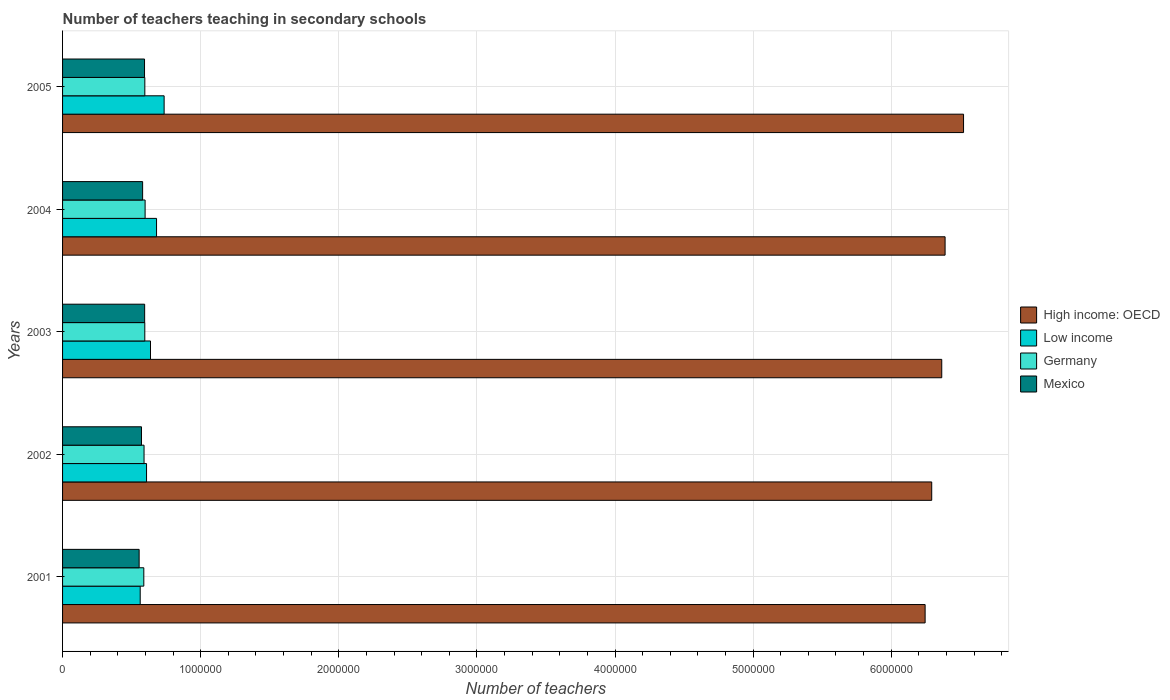How many different coloured bars are there?
Your response must be concise. 4. Are the number of bars per tick equal to the number of legend labels?
Your answer should be compact. Yes. How many bars are there on the 4th tick from the top?
Ensure brevity in your answer.  4. In how many cases, is the number of bars for a given year not equal to the number of legend labels?
Your answer should be compact. 0. What is the number of teachers teaching in secondary schools in Germany in 2005?
Make the answer very short. 5.96e+05. Across all years, what is the maximum number of teachers teaching in secondary schools in Germany?
Make the answer very short. 5.98e+05. Across all years, what is the minimum number of teachers teaching in secondary schools in Mexico?
Ensure brevity in your answer.  5.54e+05. In which year was the number of teachers teaching in secondary schools in Mexico maximum?
Ensure brevity in your answer.  2003. What is the total number of teachers teaching in secondary schools in Germany in the graph?
Make the answer very short. 2.97e+06. What is the difference between the number of teachers teaching in secondary schools in Low income in 2002 and that in 2004?
Your answer should be compact. -7.24e+04. What is the difference between the number of teachers teaching in secondary schools in High income: OECD in 2003 and the number of teachers teaching in secondary schools in Low income in 2002?
Offer a terse response. 5.76e+06. What is the average number of teachers teaching in secondary schools in Germany per year?
Provide a short and direct response. 5.93e+05. In the year 2003, what is the difference between the number of teachers teaching in secondary schools in High income: OECD and number of teachers teaching in secondary schools in Mexico?
Your response must be concise. 5.77e+06. In how many years, is the number of teachers teaching in secondary schools in Low income greater than 3800000 ?
Keep it short and to the point. 0. What is the ratio of the number of teachers teaching in secondary schools in Low income in 2001 to that in 2003?
Offer a terse response. 0.88. Is the number of teachers teaching in secondary schools in Low income in 2001 less than that in 2003?
Keep it short and to the point. Yes. Is the difference between the number of teachers teaching in secondary schools in High income: OECD in 2002 and 2003 greater than the difference between the number of teachers teaching in secondary schools in Mexico in 2002 and 2003?
Make the answer very short. No. What is the difference between the highest and the second highest number of teachers teaching in secondary schools in Germany?
Ensure brevity in your answer.  2046. What is the difference between the highest and the lowest number of teachers teaching in secondary schools in Low income?
Your response must be concise. 1.73e+05. In how many years, is the number of teachers teaching in secondary schools in Mexico greater than the average number of teachers teaching in secondary schools in Mexico taken over all years?
Keep it short and to the point. 3. Is the sum of the number of teachers teaching in secondary schools in Mexico in 2003 and 2004 greater than the maximum number of teachers teaching in secondary schools in Germany across all years?
Keep it short and to the point. Yes. Is it the case that in every year, the sum of the number of teachers teaching in secondary schools in Mexico and number of teachers teaching in secondary schools in High income: OECD is greater than the sum of number of teachers teaching in secondary schools in Low income and number of teachers teaching in secondary schools in Germany?
Offer a very short reply. Yes. What does the 2nd bar from the top in 2003 represents?
Make the answer very short. Germany. What does the 2nd bar from the bottom in 2005 represents?
Your answer should be compact. Low income. Is it the case that in every year, the sum of the number of teachers teaching in secondary schools in High income: OECD and number of teachers teaching in secondary schools in Mexico is greater than the number of teachers teaching in secondary schools in Low income?
Ensure brevity in your answer.  Yes. Are all the bars in the graph horizontal?
Keep it short and to the point. Yes. What is the difference between two consecutive major ticks on the X-axis?
Give a very brief answer. 1.00e+06. Are the values on the major ticks of X-axis written in scientific E-notation?
Keep it short and to the point. No. Does the graph contain any zero values?
Give a very brief answer. No. Does the graph contain grids?
Ensure brevity in your answer.  Yes. Where does the legend appear in the graph?
Your answer should be compact. Center right. What is the title of the graph?
Offer a very short reply. Number of teachers teaching in secondary schools. Does "Tanzania" appear as one of the legend labels in the graph?
Keep it short and to the point. No. What is the label or title of the X-axis?
Offer a very short reply. Number of teachers. What is the label or title of the Y-axis?
Keep it short and to the point. Years. What is the Number of teachers in High income: OECD in 2001?
Offer a terse response. 6.25e+06. What is the Number of teachers of Low income in 2001?
Ensure brevity in your answer.  5.62e+05. What is the Number of teachers in Germany in 2001?
Offer a terse response. 5.88e+05. What is the Number of teachers of Mexico in 2001?
Offer a terse response. 5.54e+05. What is the Number of teachers in High income: OECD in 2002?
Offer a very short reply. 6.29e+06. What is the Number of teachers in Low income in 2002?
Offer a very short reply. 6.08e+05. What is the Number of teachers in Germany in 2002?
Keep it short and to the point. 5.90e+05. What is the Number of teachers of Mexico in 2002?
Keep it short and to the point. 5.71e+05. What is the Number of teachers of High income: OECD in 2003?
Keep it short and to the point. 6.37e+06. What is the Number of teachers of Low income in 2003?
Keep it short and to the point. 6.37e+05. What is the Number of teachers of Germany in 2003?
Provide a succinct answer. 5.95e+05. What is the Number of teachers of Mexico in 2003?
Make the answer very short. 5.94e+05. What is the Number of teachers in High income: OECD in 2004?
Give a very brief answer. 6.39e+06. What is the Number of teachers in Low income in 2004?
Your answer should be compact. 6.80e+05. What is the Number of teachers in Germany in 2004?
Your answer should be compact. 5.98e+05. What is the Number of teachers in Mexico in 2004?
Offer a terse response. 5.80e+05. What is the Number of teachers of High income: OECD in 2005?
Make the answer very short. 6.52e+06. What is the Number of teachers in Low income in 2005?
Your answer should be compact. 7.35e+05. What is the Number of teachers of Germany in 2005?
Ensure brevity in your answer.  5.96e+05. What is the Number of teachers of Mexico in 2005?
Your response must be concise. 5.93e+05. Across all years, what is the maximum Number of teachers in High income: OECD?
Give a very brief answer. 6.52e+06. Across all years, what is the maximum Number of teachers of Low income?
Your answer should be compact. 7.35e+05. Across all years, what is the maximum Number of teachers in Germany?
Your response must be concise. 5.98e+05. Across all years, what is the maximum Number of teachers in Mexico?
Give a very brief answer. 5.94e+05. Across all years, what is the minimum Number of teachers of High income: OECD?
Give a very brief answer. 6.25e+06. Across all years, what is the minimum Number of teachers of Low income?
Provide a short and direct response. 5.62e+05. Across all years, what is the minimum Number of teachers in Germany?
Your answer should be compact. 5.88e+05. Across all years, what is the minimum Number of teachers of Mexico?
Make the answer very short. 5.54e+05. What is the total Number of teachers of High income: OECD in the graph?
Offer a very short reply. 3.18e+07. What is the total Number of teachers in Low income in the graph?
Ensure brevity in your answer.  3.22e+06. What is the total Number of teachers of Germany in the graph?
Your answer should be very brief. 2.97e+06. What is the total Number of teachers of Mexico in the graph?
Make the answer very short. 2.89e+06. What is the difference between the Number of teachers in High income: OECD in 2001 and that in 2002?
Provide a short and direct response. -4.78e+04. What is the difference between the Number of teachers of Low income in 2001 and that in 2002?
Provide a succinct answer. -4.59e+04. What is the difference between the Number of teachers in Germany in 2001 and that in 2002?
Your answer should be very brief. -1636. What is the difference between the Number of teachers of Mexico in 2001 and that in 2002?
Your answer should be very brief. -1.70e+04. What is the difference between the Number of teachers of High income: OECD in 2001 and that in 2003?
Offer a very short reply. -1.20e+05. What is the difference between the Number of teachers in Low income in 2001 and that in 2003?
Offer a terse response. -7.46e+04. What is the difference between the Number of teachers in Germany in 2001 and that in 2003?
Provide a short and direct response. -7059. What is the difference between the Number of teachers of Mexico in 2001 and that in 2003?
Keep it short and to the point. -4.00e+04. What is the difference between the Number of teachers in High income: OECD in 2001 and that in 2004?
Provide a succinct answer. -1.45e+05. What is the difference between the Number of teachers of Low income in 2001 and that in 2004?
Your response must be concise. -1.18e+05. What is the difference between the Number of teachers in Germany in 2001 and that in 2004?
Provide a short and direct response. -9352. What is the difference between the Number of teachers in Mexico in 2001 and that in 2004?
Offer a terse response. -2.53e+04. What is the difference between the Number of teachers in High income: OECD in 2001 and that in 2005?
Ensure brevity in your answer.  -2.78e+05. What is the difference between the Number of teachers of Low income in 2001 and that in 2005?
Keep it short and to the point. -1.73e+05. What is the difference between the Number of teachers in Germany in 2001 and that in 2005?
Offer a very short reply. -7306. What is the difference between the Number of teachers of Mexico in 2001 and that in 2005?
Make the answer very short. -3.90e+04. What is the difference between the Number of teachers of High income: OECD in 2002 and that in 2003?
Make the answer very short. -7.26e+04. What is the difference between the Number of teachers of Low income in 2002 and that in 2003?
Your response must be concise. -2.87e+04. What is the difference between the Number of teachers of Germany in 2002 and that in 2003?
Give a very brief answer. -5423. What is the difference between the Number of teachers in Mexico in 2002 and that in 2003?
Keep it short and to the point. -2.30e+04. What is the difference between the Number of teachers of High income: OECD in 2002 and that in 2004?
Provide a short and direct response. -9.68e+04. What is the difference between the Number of teachers of Low income in 2002 and that in 2004?
Offer a very short reply. -7.24e+04. What is the difference between the Number of teachers in Germany in 2002 and that in 2004?
Make the answer very short. -7716. What is the difference between the Number of teachers of Mexico in 2002 and that in 2004?
Your answer should be very brief. -8337. What is the difference between the Number of teachers in High income: OECD in 2002 and that in 2005?
Give a very brief answer. -2.30e+05. What is the difference between the Number of teachers of Low income in 2002 and that in 2005?
Your answer should be compact. -1.27e+05. What is the difference between the Number of teachers of Germany in 2002 and that in 2005?
Provide a succinct answer. -5670. What is the difference between the Number of teachers in Mexico in 2002 and that in 2005?
Provide a succinct answer. -2.21e+04. What is the difference between the Number of teachers of High income: OECD in 2003 and that in 2004?
Your answer should be very brief. -2.42e+04. What is the difference between the Number of teachers of Low income in 2003 and that in 2004?
Keep it short and to the point. -4.37e+04. What is the difference between the Number of teachers in Germany in 2003 and that in 2004?
Provide a succinct answer. -2293. What is the difference between the Number of teachers in Mexico in 2003 and that in 2004?
Keep it short and to the point. 1.47e+04. What is the difference between the Number of teachers in High income: OECD in 2003 and that in 2005?
Ensure brevity in your answer.  -1.58e+05. What is the difference between the Number of teachers in Low income in 2003 and that in 2005?
Offer a very short reply. -9.87e+04. What is the difference between the Number of teachers of Germany in 2003 and that in 2005?
Your answer should be compact. -247. What is the difference between the Number of teachers of Mexico in 2003 and that in 2005?
Offer a very short reply. 937. What is the difference between the Number of teachers of High income: OECD in 2004 and that in 2005?
Your answer should be very brief. -1.34e+05. What is the difference between the Number of teachers in Low income in 2004 and that in 2005?
Make the answer very short. -5.50e+04. What is the difference between the Number of teachers in Germany in 2004 and that in 2005?
Ensure brevity in your answer.  2046. What is the difference between the Number of teachers of Mexico in 2004 and that in 2005?
Provide a succinct answer. -1.37e+04. What is the difference between the Number of teachers in High income: OECD in 2001 and the Number of teachers in Low income in 2002?
Your answer should be compact. 5.64e+06. What is the difference between the Number of teachers of High income: OECD in 2001 and the Number of teachers of Germany in 2002?
Your answer should be compact. 5.66e+06. What is the difference between the Number of teachers in High income: OECD in 2001 and the Number of teachers in Mexico in 2002?
Provide a short and direct response. 5.67e+06. What is the difference between the Number of teachers in Low income in 2001 and the Number of teachers in Germany in 2002?
Make the answer very short. -2.78e+04. What is the difference between the Number of teachers of Low income in 2001 and the Number of teachers of Mexico in 2002?
Your response must be concise. -9230.75. What is the difference between the Number of teachers of Germany in 2001 and the Number of teachers of Mexico in 2002?
Offer a very short reply. 1.70e+04. What is the difference between the Number of teachers in High income: OECD in 2001 and the Number of teachers in Low income in 2003?
Keep it short and to the point. 5.61e+06. What is the difference between the Number of teachers of High income: OECD in 2001 and the Number of teachers of Germany in 2003?
Your answer should be very brief. 5.65e+06. What is the difference between the Number of teachers in High income: OECD in 2001 and the Number of teachers in Mexico in 2003?
Offer a terse response. 5.65e+06. What is the difference between the Number of teachers in Low income in 2001 and the Number of teachers in Germany in 2003?
Provide a short and direct response. -3.32e+04. What is the difference between the Number of teachers in Low income in 2001 and the Number of teachers in Mexico in 2003?
Give a very brief answer. -3.22e+04. What is the difference between the Number of teachers in Germany in 2001 and the Number of teachers in Mexico in 2003?
Make the answer very short. -6059. What is the difference between the Number of teachers of High income: OECD in 2001 and the Number of teachers of Low income in 2004?
Offer a terse response. 5.57e+06. What is the difference between the Number of teachers in High income: OECD in 2001 and the Number of teachers in Germany in 2004?
Offer a very short reply. 5.65e+06. What is the difference between the Number of teachers in High income: OECD in 2001 and the Number of teachers in Mexico in 2004?
Your response must be concise. 5.67e+06. What is the difference between the Number of teachers of Low income in 2001 and the Number of teachers of Germany in 2004?
Your response must be concise. -3.55e+04. What is the difference between the Number of teachers in Low income in 2001 and the Number of teachers in Mexico in 2004?
Offer a very short reply. -1.76e+04. What is the difference between the Number of teachers of Germany in 2001 and the Number of teachers of Mexico in 2004?
Offer a very short reply. 8615. What is the difference between the Number of teachers in High income: OECD in 2001 and the Number of teachers in Low income in 2005?
Your answer should be very brief. 5.51e+06. What is the difference between the Number of teachers in High income: OECD in 2001 and the Number of teachers in Germany in 2005?
Offer a terse response. 5.65e+06. What is the difference between the Number of teachers of High income: OECD in 2001 and the Number of teachers of Mexico in 2005?
Provide a succinct answer. 5.65e+06. What is the difference between the Number of teachers in Low income in 2001 and the Number of teachers in Germany in 2005?
Your response must be concise. -3.35e+04. What is the difference between the Number of teachers in Low income in 2001 and the Number of teachers in Mexico in 2005?
Your answer should be compact. -3.13e+04. What is the difference between the Number of teachers of Germany in 2001 and the Number of teachers of Mexico in 2005?
Offer a very short reply. -5122. What is the difference between the Number of teachers in High income: OECD in 2002 and the Number of teachers in Low income in 2003?
Provide a short and direct response. 5.66e+06. What is the difference between the Number of teachers of High income: OECD in 2002 and the Number of teachers of Germany in 2003?
Your response must be concise. 5.70e+06. What is the difference between the Number of teachers of High income: OECD in 2002 and the Number of teachers of Mexico in 2003?
Make the answer very short. 5.70e+06. What is the difference between the Number of teachers in Low income in 2002 and the Number of teachers in Germany in 2003?
Make the answer very short. 1.27e+04. What is the difference between the Number of teachers in Low income in 2002 and the Number of teachers in Mexico in 2003?
Your answer should be very brief. 1.37e+04. What is the difference between the Number of teachers of Germany in 2002 and the Number of teachers of Mexico in 2003?
Offer a very short reply. -4423. What is the difference between the Number of teachers of High income: OECD in 2002 and the Number of teachers of Low income in 2004?
Ensure brevity in your answer.  5.61e+06. What is the difference between the Number of teachers in High income: OECD in 2002 and the Number of teachers in Germany in 2004?
Give a very brief answer. 5.70e+06. What is the difference between the Number of teachers in High income: OECD in 2002 and the Number of teachers in Mexico in 2004?
Offer a terse response. 5.71e+06. What is the difference between the Number of teachers in Low income in 2002 and the Number of teachers in Germany in 2004?
Ensure brevity in your answer.  1.04e+04. What is the difference between the Number of teachers in Low income in 2002 and the Number of teachers in Mexico in 2004?
Make the answer very short. 2.83e+04. What is the difference between the Number of teachers of Germany in 2002 and the Number of teachers of Mexico in 2004?
Offer a very short reply. 1.03e+04. What is the difference between the Number of teachers of High income: OECD in 2002 and the Number of teachers of Low income in 2005?
Provide a succinct answer. 5.56e+06. What is the difference between the Number of teachers of High income: OECD in 2002 and the Number of teachers of Germany in 2005?
Your response must be concise. 5.70e+06. What is the difference between the Number of teachers in High income: OECD in 2002 and the Number of teachers in Mexico in 2005?
Ensure brevity in your answer.  5.70e+06. What is the difference between the Number of teachers of Low income in 2002 and the Number of teachers of Germany in 2005?
Keep it short and to the point. 1.24e+04. What is the difference between the Number of teachers of Low income in 2002 and the Number of teachers of Mexico in 2005?
Offer a very short reply. 1.46e+04. What is the difference between the Number of teachers in Germany in 2002 and the Number of teachers in Mexico in 2005?
Your answer should be compact. -3486. What is the difference between the Number of teachers in High income: OECD in 2003 and the Number of teachers in Low income in 2004?
Make the answer very short. 5.69e+06. What is the difference between the Number of teachers in High income: OECD in 2003 and the Number of teachers in Germany in 2004?
Your answer should be compact. 5.77e+06. What is the difference between the Number of teachers in High income: OECD in 2003 and the Number of teachers in Mexico in 2004?
Give a very brief answer. 5.79e+06. What is the difference between the Number of teachers of Low income in 2003 and the Number of teachers of Germany in 2004?
Offer a very short reply. 3.91e+04. What is the difference between the Number of teachers of Low income in 2003 and the Number of teachers of Mexico in 2004?
Your answer should be compact. 5.70e+04. What is the difference between the Number of teachers in Germany in 2003 and the Number of teachers in Mexico in 2004?
Give a very brief answer. 1.57e+04. What is the difference between the Number of teachers in High income: OECD in 2003 and the Number of teachers in Low income in 2005?
Offer a very short reply. 5.63e+06. What is the difference between the Number of teachers in High income: OECD in 2003 and the Number of teachers in Germany in 2005?
Provide a succinct answer. 5.77e+06. What is the difference between the Number of teachers in High income: OECD in 2003 and the Number of teachers in Mexico in 2005?
Provide a short and direct response. 5.77e+06. What is the difference between the Number of teachers in Low income in 2003 and the Number of teachers in Germany in 2005?
Give a very brief answer. 4.11e+04. What is the difference between the Number of teachers of Low income in 2003 and the Number of teachers of Mexico in 2005?
Your answer should be compact. 4.33e+04. What is the difference between the Number of teachers of Germany in 2003 and the Number of teachers of Mexico in 2005?
Your answer should be very brief. 1937. What is the difference between the Number of teachers of High income: OECD in 2004 and the Number of teachers of Low income in 2005?
Make the answer very short. 5.65e+06. What is the difference between the Number of teachers of High income: OECD in 2004 and the Number of teachers of Germany in 2005?
Offer a terse response. 5.79e+06. What is the difference between the Number of teachers of High income: OECD in 2004 and the Number of teachers of Mexico in 2005?
Your response must be concise. 5.80e+06. What is the difference between the Number of teachers of Low income in 2004 and the Number of teachers of Germany in 2005?
Offer a terse response. 8.48e+04. What is the difference between the Number of teachers in Low income in 2004 and the Number of teachers in Mexico in 2005?
Your response must be concise. 8.70e+04. What is the difference between the Number of teachers of Germany in 2004 and the Number of teachers of Mexico in 2005?
Keep it short and to the point. 4230. What is the average Number of teachers of High income: OECD per year?
Your answer should be very brief. 6.36e+06. What is the average Number of teachers of Low income per year?
Your response must be concise. 6.45e+05. What is the average Number of teachers of Germany per year?
Make the answer very short. 5.93e+05. What is the average Number of teachers of Mexico per year?
Your response must be concise. 5.79e+05. In the year 2001, what is the difference between the Number of teachers of High income: OECD and Number of teachers of Low income?
Ensure brevity in your answer.  5.68e+06. In the year 2001, what is the difference between the Number of teachers of High income: OECD and Number of teachers of Germany?
Keep it short and to the point. 5.66e+06. In the year 2001, what is the difference between the Number of teachers in High income: OECD and Number of teachers in Mexico?
Provide a succinct answer. 5.69e+06. In the year 2001, what is the difference between the Number of teachers in Low income and Number of teachers in Germany?
Offer a very short reply. -2.62e+04. In the year 2001, what is the difference between the Number of teachers of Low income and Number of teachers of Mexico?
Ensure brevity in your answer.  7721.25. In the year 2001, what is the difference between the Number of teachers of Germany and Number of teachers of Mexico?
Give a very brief answer. 3.39e+04. In the year 2002, what is the difference between the Number of teachers in High income: OECD and Number of teachers in Low income?
Offer a very short reply. 5.69e+06. In the year 2002, what is the difference between the Number of teachers in High income: OECD and Number of teachers in Germany?
Your response must be concise. 5.70e+06. In the year 2002, what is the difference between the Number of teachers in High income: OECD and Number of teachers in Mexico?
Keep it short and to the point. 5.72e+06. In the year 2002, what is the difference between the Number of teachers of Low income and Number of teachers of Germany?
Provide a short and direct response. 1.81e+04. In the year 2002, what is the difference between the Number of teachers of Low income and Number of teachers of Mexico?
Provide a short and direct response. 3.67e+04. In the year 2002, what is the difference between the Number of teachers of Germany and Number of teachers of Mexico?
Your answer should be very brief. 1.86e+04. In the year 2003, what is the difference between the Number of teachers in High income: OECD and Number of teachers in Low income?
Keep it short and to the point. 5.73e+06. In the year 2003, what is the difference between the Number of teachers of High income: OECD and Number of teachers of Germany?
Give a very brief answer. 5.77e+06. In the year 2003, what is the difference between the Number of teachers in High income: OECD and Number of teachers in Mexico?
Keep it short and to the point. 5.77e+06. In the year 2003, what is the difference between the Number of teachers in Low income and Number of teachers in Germany?
Provide a succinct answer. 4.14e+04. In the year 2003, what is the difference between the Number of teachers of Low income and Number of teachers of Mexico?
Your answer should be compact. 4.24e+04. In the year 2004, what is the difference between the Number of teachers of High income: OECD and Number of teachers of Low income?
Your response must be concise. 5.71e+06. In the year 2004, what is the difference between the Number of teachers in High income: OECD and Number of teachers in Germany?
Provide a short and direct response. 5.79e+06. In the year 2004, what is the difference between the Number of teachers in High income: OECD and Number of teachers in Mexico?
Keep it short and to the point. 5.81e+06. In the year 2004, what is the difference between the Number of teachers in Low income and Number of teachers in Germany?
Your answer should be very brief. 8.28e+04. In the year 2004, what is the difference between the Number of teachers in Low income and Number of teachers in Mexico?
Give a very brief answer. 1.01e+05. In the year 2004, what is the difference between the Number of teachers of Germany and Number of teachers of Mexico?
Keep it short and to the point. 1.80e+04. In the year 2005, what is the difference between the Number of teachers of High income: OECD and Number of teachers of Low income?
Your answer should be very brief. 5.79e+06. In the year 2005, what is the difference between the Number of teachers of High income: OECD and Number of teachers of Germany?
Ensure brevity in your answer.  5.93e+06. In the year 2005, what is the difference between the Number of teachers of High income: OECD and Number of teachers of Mexico?
Your answer should be compact. 5.93e+06. In the year 2005, what is the difference between the Number of teachers of Low income and Number of teachers of Germany?
Offer a very short reply. 1.40e+05. In the year 2005, what is the difference between the Number of teachers of Low income and Number of teachers of Mexico?
Provide a short and direct response. 1.42e+05. In the year 2005, what is the difference between the Number of teachers of Germany and Number of teachers of Mexico?
Give a very brief answer. 2184. What is the ratio of the Number of teachers in High income: OECD in 2001 to that in 2002?
Make the answer very short. 0.99. What is the ratio of the Number of teachers of Low income in 2001 to that in 2002?
Provide a succinct answer. 0.92. What is the ratio of the Number of teachers in Germany in 2001 to that in 2002?
Keep it short and to the point. 1. What is the ratio of the Number of teachers in Mexico in 2001 to that in 2002?
Your answer should be very brief. 0.97. What is the ratio of the Number of teachers in High income: OECD in 2001 to that in 2003?
Your answer should be very brief. 0.98. What is the ratio of the Number of teachers of Low income in 2001 to that in 2003?
Give a very brief answer. 0.88. What is the ratio of the Number of teachers of Germany in 2001 to that in 2003?
Provide a succinct answer. 0.99. What is the ratio of the Number of teachers in Mexico in 2001 to that in 2003?
Keep it short and to the point. 0.93. What is the ratio of the Number of teachers of High income: OECD in 2001 to that in 2004?
Offer a terse response. 0.98. What is the ratio of the Number of teachers of Low income in 2001 to that in 2004?
Provide a succinct answer. 0.83. What is the ratio of the Number of teachers of Germany in 2001 to that in 2004?
Keep it short and to the point. 0.98. What is the ratio of the Number of teachers in Mexico in 2001 to that in 2004?
Provide a short and direct response. 0.96. What is the ratio of the Number of teachers in High income: OECD in 2001 to that in 2005?
Your response must be concise. 0.96. What is the ratio of the Number of teachers of Low income in 2001 to that in 2005?
Offer a very short reply. 0.76. What is the ratio of the Number of teachers of Mexico in 2001 to that in 2005?
Ensure brevity in your answer.  0.93. What is the ratio of the Number of teachers in High income: OECD in 2002 to that in 2003?
Offer a very short reply. 0.99. What is the ratio of the Number of teachers of Low income in 2002 to that in 2003?
Make the answer very short. 0.95. What is the ratio of the Number of teachers in Germany in 2002 to that in 2003?
Keep it short and to the point. 0.99. What is the ratio of the Number of teachers in Mexico in 2002 to that in 2003?
Your answer should be compact. 0.96. What is the ratio of the Number of teachers of High income: OECD in 2002 to that in 2004?
Keep it short and to the point. 0.98. What is the ratio of the Number of teachers of Low income in 2002 to that in 2004?
Ensure brevity in your answer.  0.89. What is the ratio of the Number of teachers of Germany in 2002 to that in 2004?
Give a very brief answer. 0.99. What is the ratio of the Number of teachers in Mexico in 2002 to that in 2004?
Your answer should be compact. 0.99. What is the ratio of the Number of teachers of High income: OECD in 2002 to that in 2005?
Your response must be concise. 0.96. What is the ratio of the Number of teachers of Low income in 2002 to that in 2005?
Give a very brief answer. 0.83. What is the ratio of the Number of teachers of Germany in 2002 to that in 2005?
Provide a short and direct response. 0.99. What is the ratio of the Number of teachers of Mexico in 2002 to that in 2005?
Ensure brevity in your answer.  0.96. What is the ratio of the Number of teachers of High income: OECD in 2003 to that in 2004?
Ensure brevity in your answer.  1. What is the ratio of the Number of teachers of Low income in 2003 to that in 2004?
Provide a succinct answer. 0.94. What is the ratio of the Number of teachers of Mexico in 2003 to that in 2004?
Your answer should be compact. 1.03. What is the ratio of the Number of teachers of High income: OECD in 2003 to that in 2005?
Your response must be concise. 0.98. What is the ratio of the Number of teachers in Low income in 2003 to that in 2005?
Make the answer very short. 0.87. What is the ratio of the Number of teachers of Germany in 2003 to that in 2005?
Make the answer very short. 1. What is the ratio of the Number of teachers in Mexico in 2003 to that in 2005?
Keep it short and to the point. 1. What is the ratio of the Number of teachers of High income: OECD in 2004 to that in 2005?
Offer a very short reply. 0.98. What is the ratio of the Number of teachers of Low income in 2004 to that in 2005?
Offer a very short reply. 0.93. What is the ratio of the Number of teachers in Germany in 2004 to that in 2005?
Offer a terse response. 1. What is the ratio of the Number of teachers of Mexico in 2004 to that in 2005?
Give a very brief answer. 0.98. What is the difference between the highest and the second highest Number of teachers in High income: OECD?
Your answer should be very brief. 1.34e+05. What is the difference between the highest and the second highest Number of teachers in Low income?
Offer a terse response. 5.50e+04. What is the difference between the highest and the second highest Number of teachers of Germany?
Your answer should be very brief. 2046. What is the difference between the highest and the second highest Number of teachers of Mexico?
Ensure brevity in your answer.  937. What is the difference between the highest and the lowest Number of teachers in High income: OECD?
Provide a succinct answer. 2.78e+05. What is the difference between the highest and the lowest Number of teachers of Low income?
Offer a terse response. 1.73e+05. What is the difference between the highest and the lowest Number of teachers in Germany?
Your response must be concise. 9352. What is the difference between the highest and the lowest Number of teachers of Mexico?
Your answer should be very brief. 4.00e+04. 